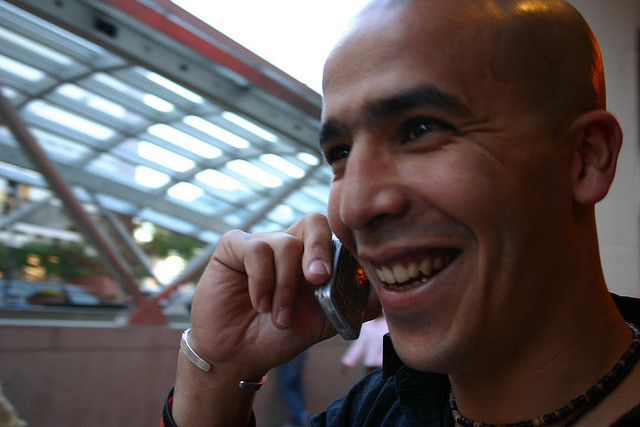<image>What color is the vehicle behind the fence? It is unknown what color is the vehicle behind the fence. There might not even be a vehicle behind the fence. What color is the vehicle behind the fence? I don't know what color is the vehicle behind the fence. It can be white, blue, red, black or no vehicle at all. 